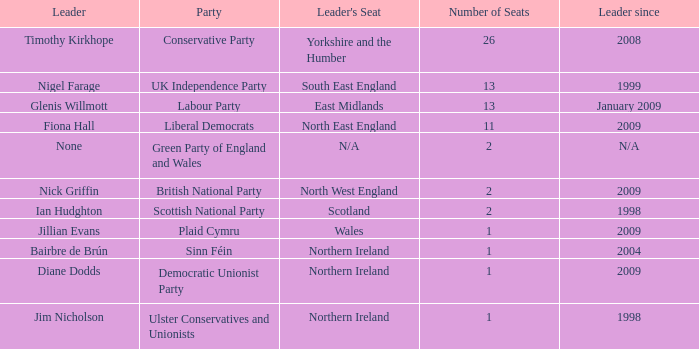What is Jillian Evans highest number of seats? 1.0. 